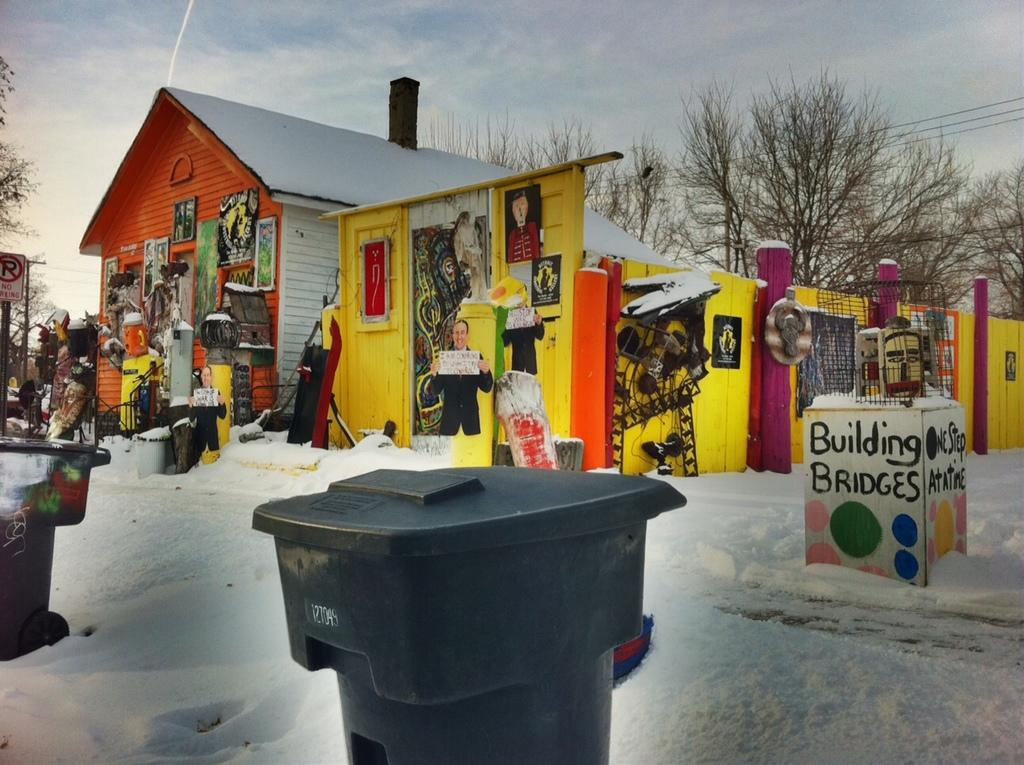<image>
Create a compact narrative representing the image presented. A very colorful house with a Building Bridges sign 